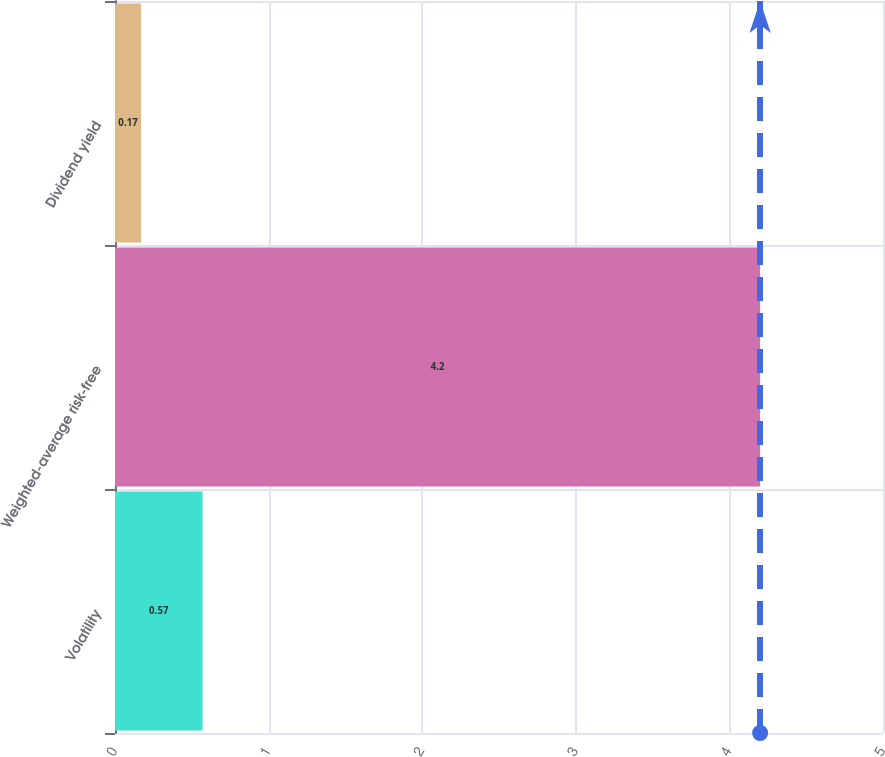<chart> <loc_0><loc_0><loc_500><loc_500><bar_chart><fcel>Volatility<fcel>Weighted-average risk-free<fcel>Dividend yield<nl><fcel>0.57<fcel>4.2<fcel>0.17<nl></chart> 